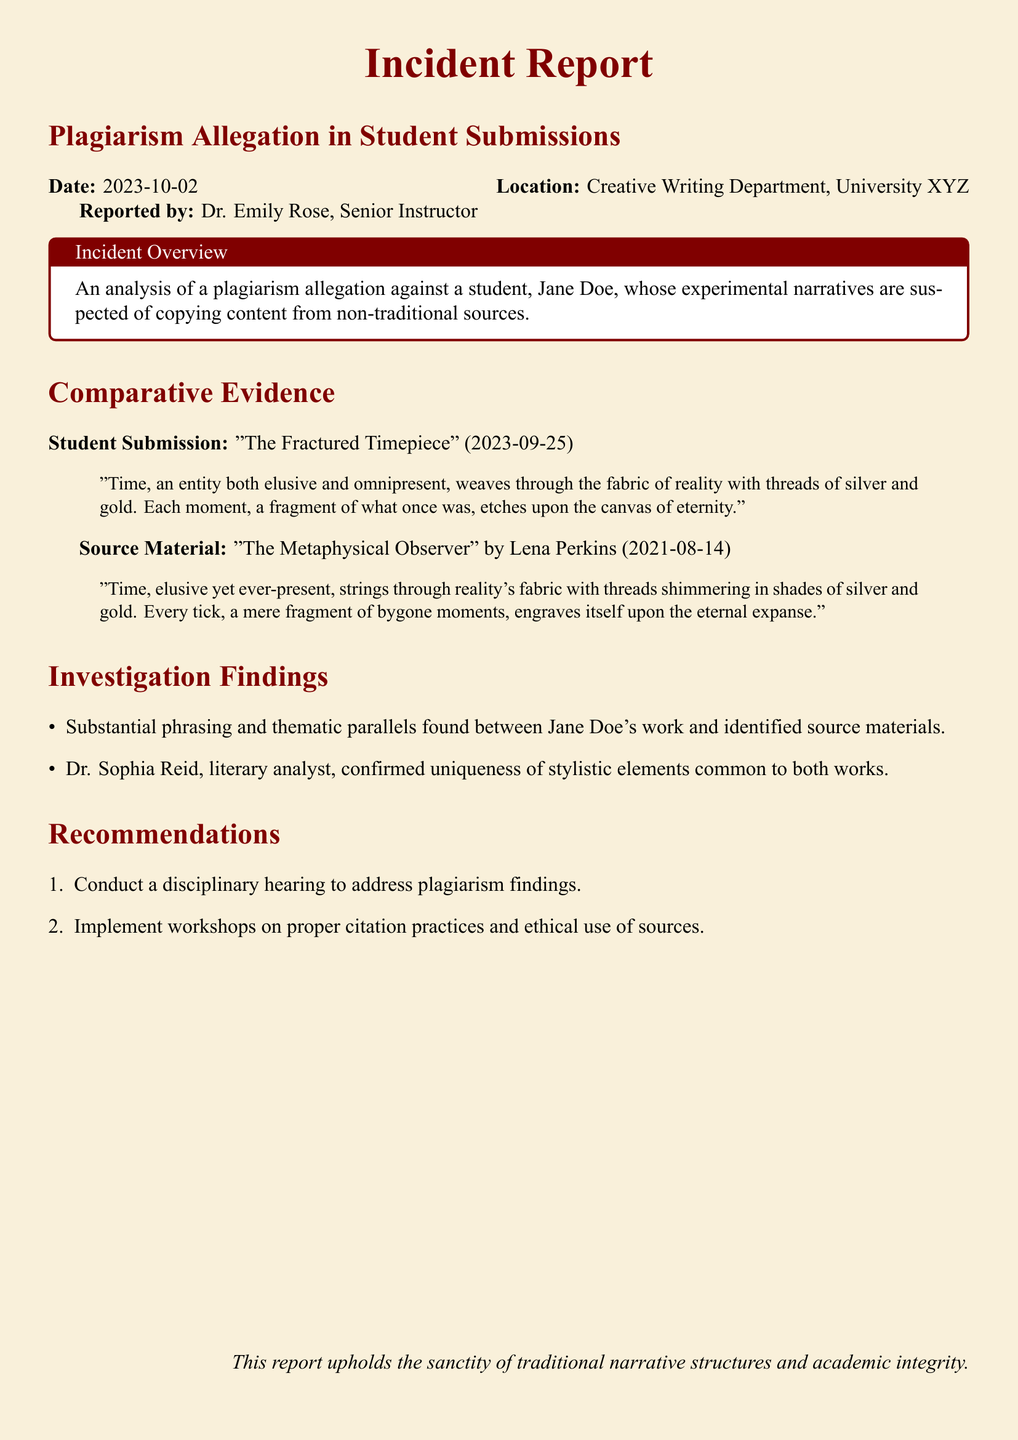What is the date of the report? The date is stated in the report, which is 2023-10-02.
Answer: 2023-10-02 Who reported the plagiarism allegation? The name of the person who reported the incident is given in the document.
Answer: Dr. Emily Rose What is the title of the student's submission? The title of the student's work is mentioned in the incident report.
Answer: The Fractured Timepiece Who is the author of the source material? The document specifies the author of the original material in the comparative evidence section.
Answer: Lena Perkins What is a key theme noted in both the student submission and the source material? This theme is described in both texts, highlighting their similarities.
Answer: Time What action is recommended regarding citation practices? The report outlines a specific recommendation related to citation practices.
Answer: Implement workshops What does Dr. Sophia Reid confirm regarding the works? The document includes findings related to the stylistic elements of the submissions.
Answer: Uniqueness of stylistic elements What is the purpose of the incident report? The report's purpose is reflected in a statement toward the end, emphasizing its main focus.
Answer: Uphold academic integrity 